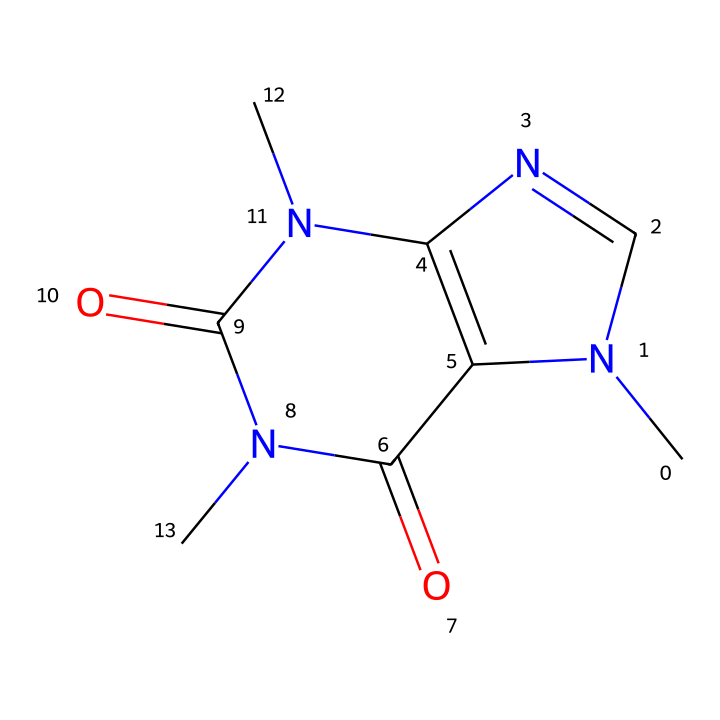What is the main pharmacological effect of this chemical? This chemical is known to exhibit stimulant properties, which enhance alertness and reduce fatigue, commonly associated with drugs like caffeine.
Answer: stimulant How many nitrogen atoms are present in this chemical? By analyzing the chemical structure, we can identify three nitrogen atoms listed clearly within the SMILES representation.
Answer: three What type of drug is this compound classified as? Given the structure and known effects of similar compounds, this is classified as a xanthine.
Answer: xanthine How does this chemical primarily affect muscle performance? The compound increases the release of adrenaline, leading to enhanced physical performance and endurance during athletic activities.
Answer: increases adrenaline What is the molecular formula of this compound? By interpreting the SMILES structure, we can derive the molecular formula, which is C6H6N4O2.
Answer: C6H6N4O2 